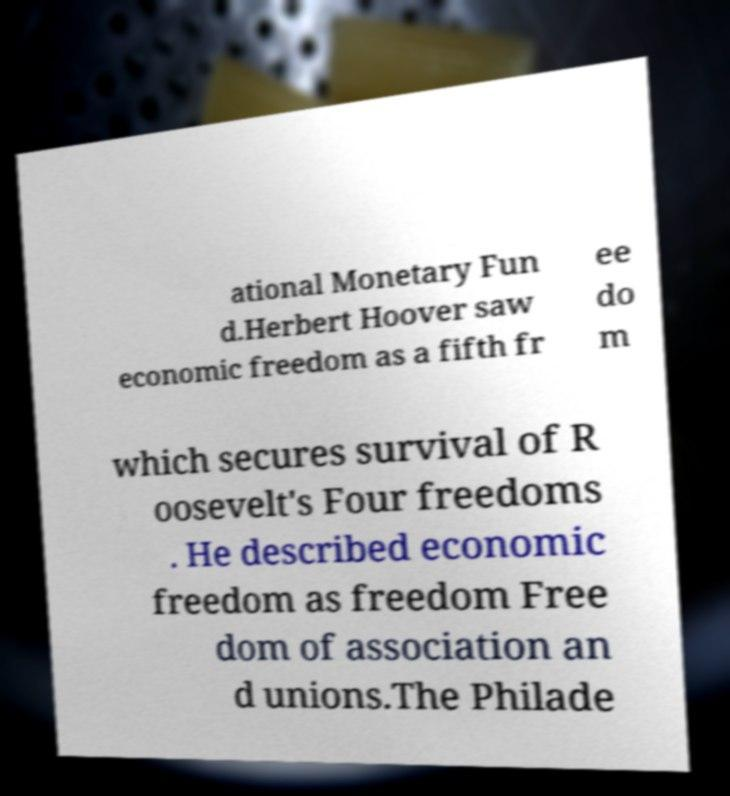Please read and relay the text visible in this image. What does it say? ational Monetary Fun d.Herbert Hoover saw economic freedom as a fifth fr ee do m which secures survival of R oosevelt's Four freedoms . He described economic freedom as freedom Free dom of association an d unions.The Philade 